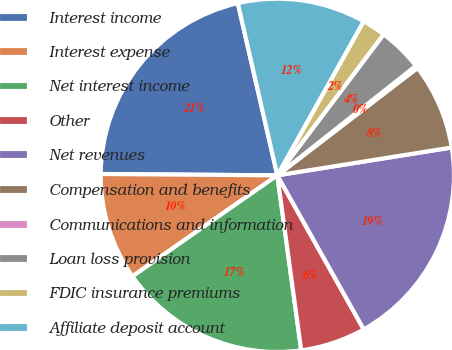Convert chart to OTSL. <chart><loc_0><loc_0><loc_500><loc_500><pie_chart><fcel>Interest income<fcel>Interest expense<fcel>Net interest income<fcel>Other<fcel>Net revenues<fcel>Compensation and benefits<fcel>Communications and information<fcel>Loan loss provision<fcel>FDIC insurance premiums<fcel>Affiliate deposit account<nl><fcel>21.29%<fcel>9.81%<fcel>17.47%<fcel>5.98%<fcel>19.38%<fcel>7.89%<fcel>0.24%<fcel>4.07%<fcel>2.15%<fcel>11.72%<nl></chart> 